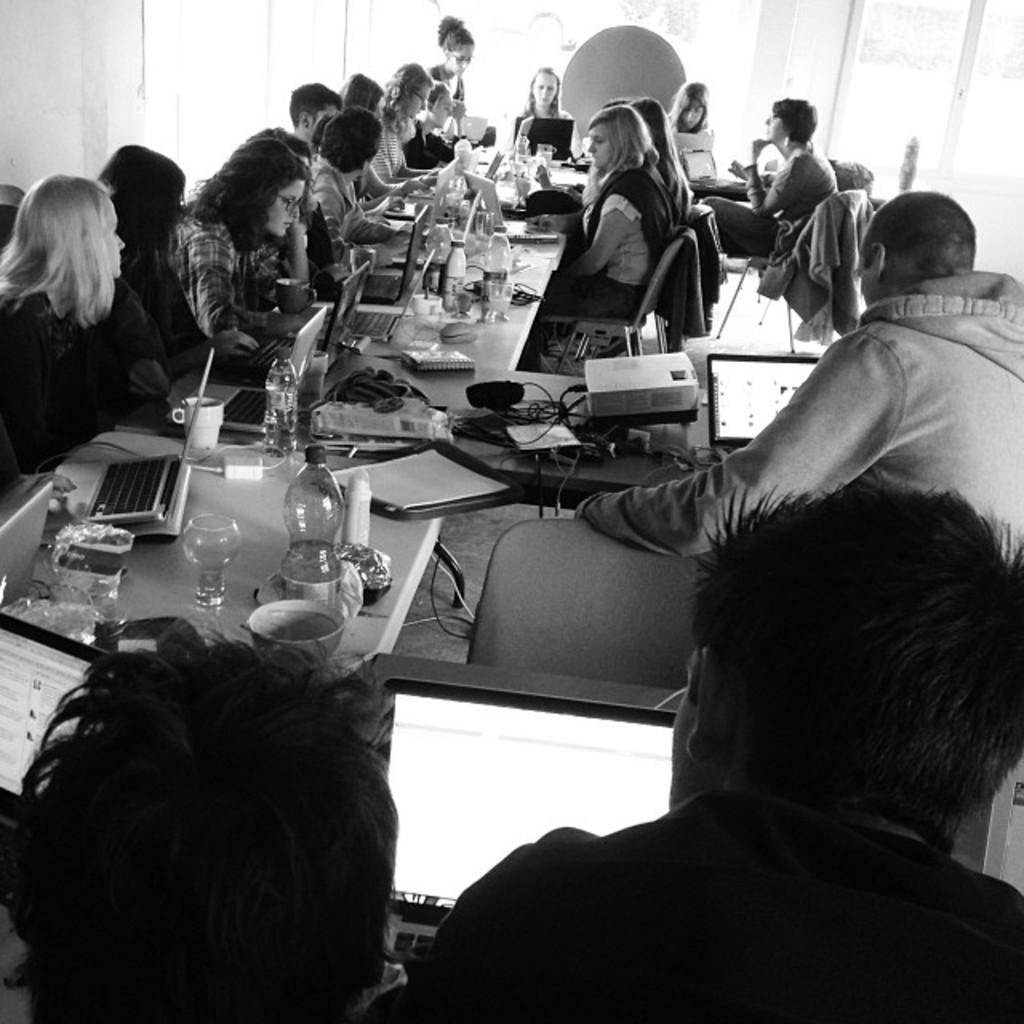What are the people in the image doing? The people in the image are sitting around the table. What objects can be seen on the table? There are laptops, glasses, bottles, cups, and a projector on the table. What might the people be using the laptops for? It is not clear from the image what the people are using the laptops for, but they could be working or browsing the internet. What is the purpose of the projector in the image? The projector might be used for displaying presentations or videos during a meeting or gathering. What type of crack can be heard in the background of the image? There is no sound or crack present in the image, as it is a still image. 